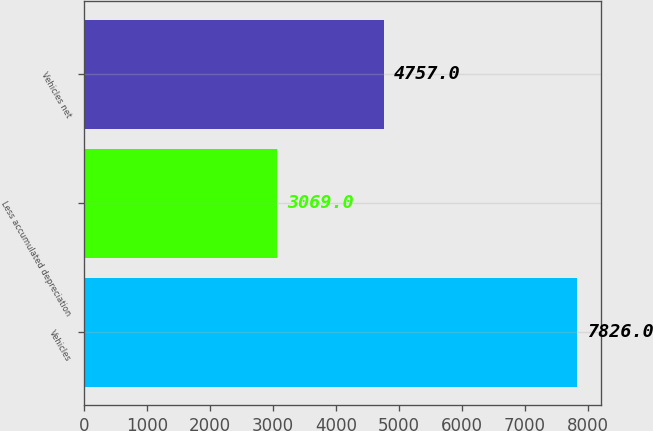Convert chart to OTSL. <chart><loc_0><loc_0><loc_500><loc_500><bar_chart><fcel>Vehicles<fcel>Less accumulated depreciation<fcel>Vehicles net<nl><fcel>7826<fcel>3069<fcel>4757<nl></chart> 